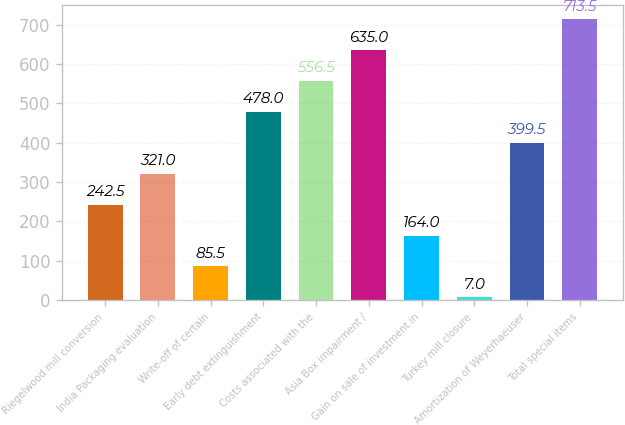<chart> <loc_0><loc_0><loc_500><loc_500><bar_chart><fcel>Riegelwood mill conversion<fcel>India Packaging evaluation<fcel>Write-off of certain<fcel>Early debt extinguishment<fcel>Costs associated with the<fcel>Asia Box impairment /<fcel>Gain on sale of investment in<fcel>Turkey mill closure<fcel>Amortization of Weyerhaeuser<fcel>Total special items<nl><fcel>242.5<fcel>321<fcel>85.5<fcel>478<fcel>556.5<fcel>635<fcel>164<fcel>7<fcel>399.5<fcel>713.5<nl></chart> 